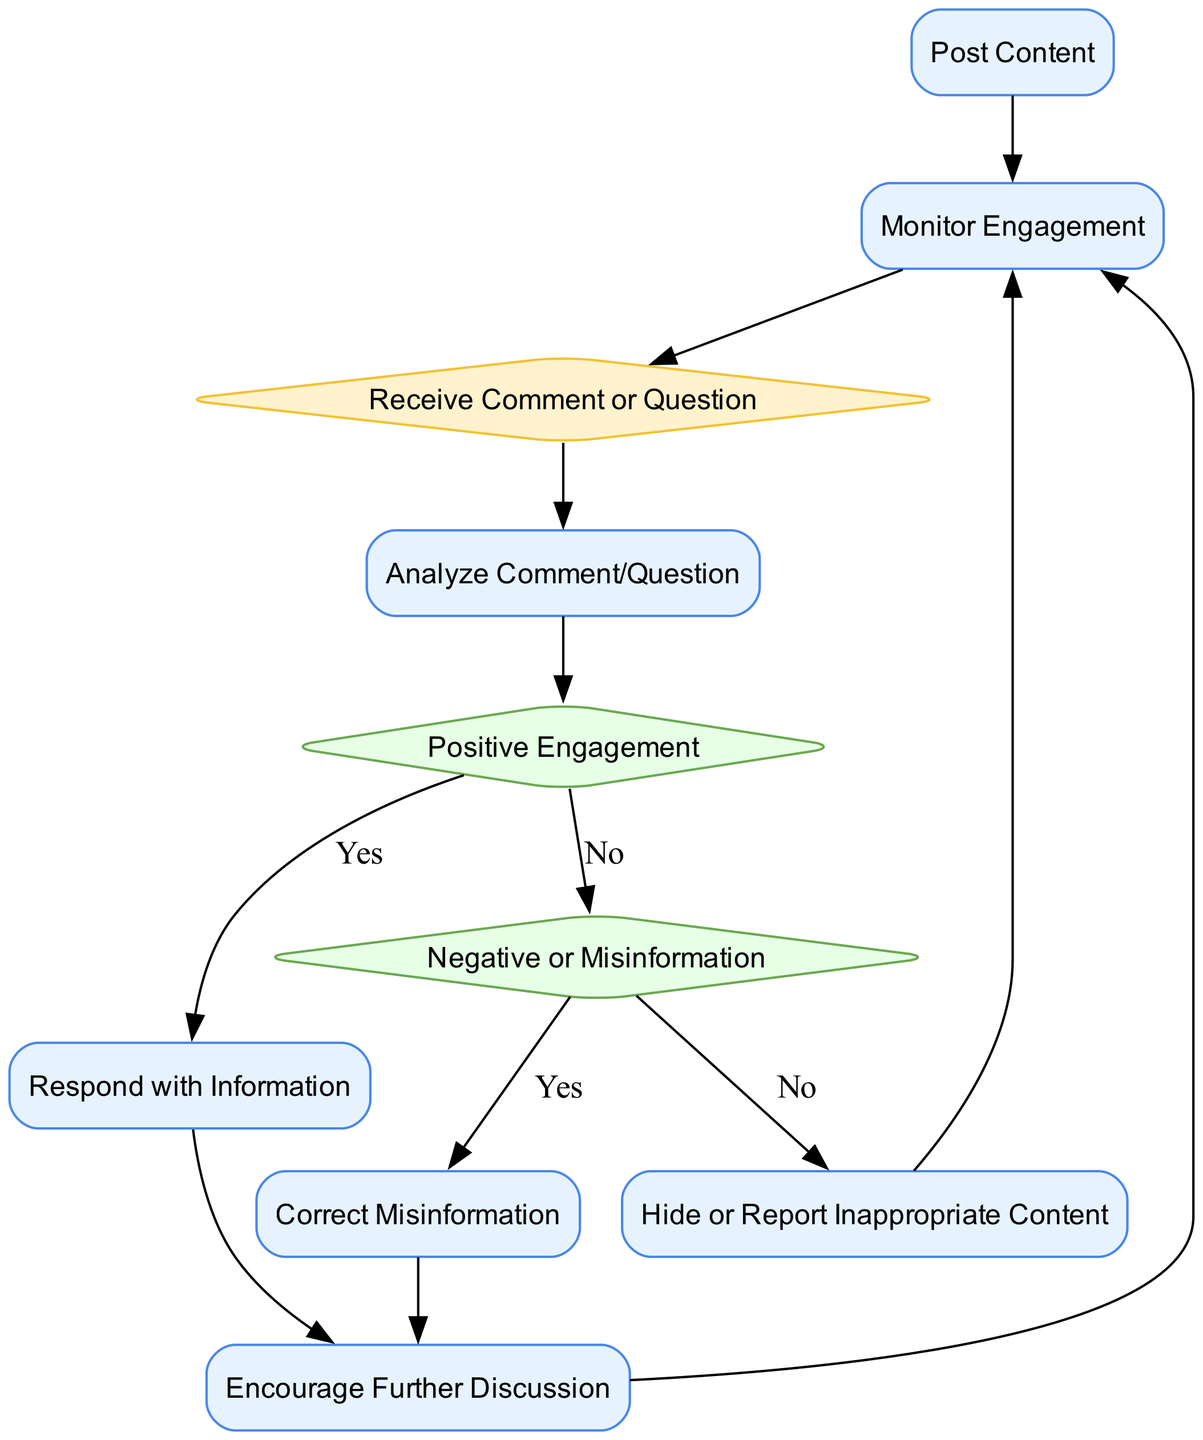What is the first action in the diagram? The diagram begins with the action node labeled "Post Content," which indicates sharing a post about Amazon deforestation on social media.
Answer: Post Content How many decision nodes are present in the diagram? There are two decision nodes: "Positive Engagement" and "Negative or Misinformation." Therefore, counting these gives a total of two decision nodes.
Answer: 2 What follows the "Analyze Comment/Question" action? After "Analyze Comment/Question," the flow leads to the decision node "Positive Engagement," indicating a choice based on the nature of the comment or question.
Answer: Positive Engagement What action is taken if the comment is negative? If the comment is negative or misinformation, the next action taken is "Correct Misinformation," where an accurate response is provided with credible references.
Answer: Correct Misinformation What happens after responding with information? Following the action "Respond with Information," the next action is "Encourage Further Discussion," inviting more interaction and conversation from the audience.
Answer: Encourage Further Discussion Which action occurs if content is inappropriate? In case the content is inappropriate, the action taken is "Hide or Report Inappropriate Content," which involves dealing with abusive or policy-violating remarks.
Answer: Hide or Report Inappropriate Content How does the diagram loop back to monitoring engagement? The flow loops back to "Monitor Engagement" after completing the actions "Encourage Further Discussion" or "Hide or Report Inappropriate Content," indicating a continuous feedback mechanism to track audience responses.
Answer: Monitor Engagement 